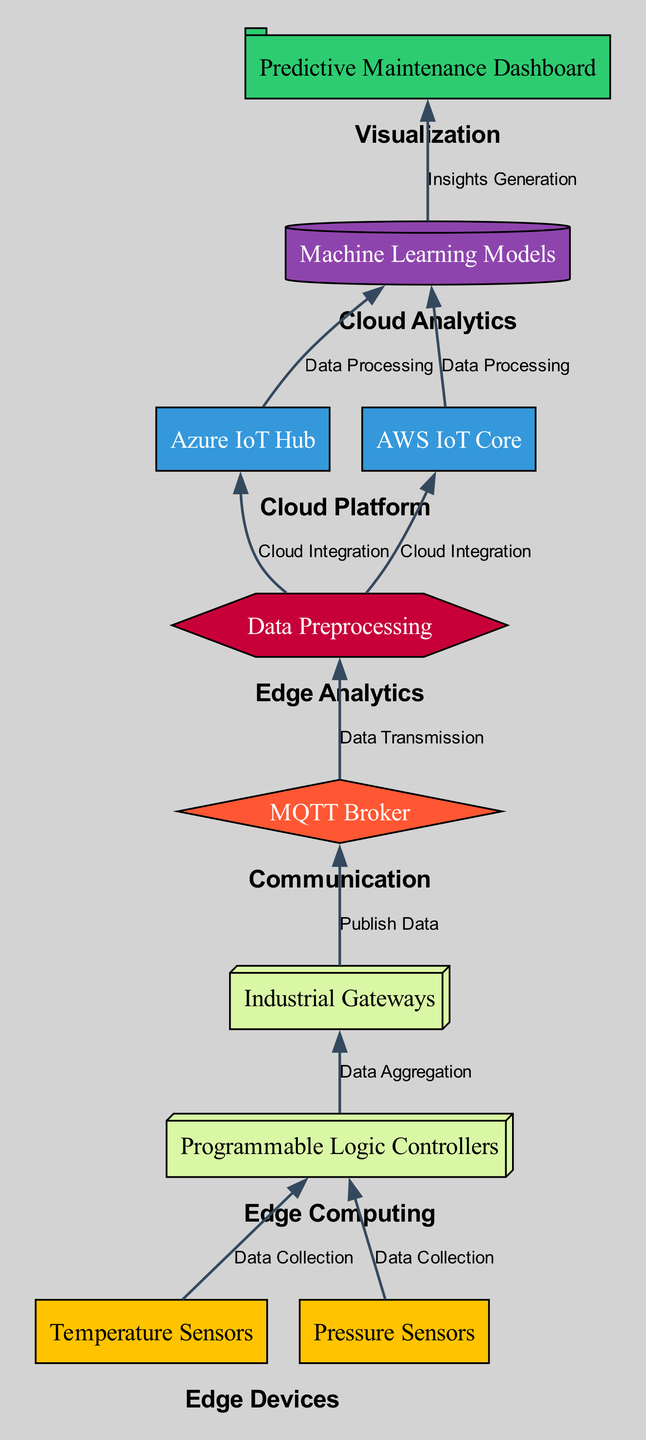What are the edge devices in the diagram? The edge devices listed in the diagram are Temperature Sensors and Pressure Sensors. They are represented as nodes with the category "Edge Devices."
Answer: Temperature Sensors, Pressure Sensors How many cloud platforms are shown? The diagram includes two cloud platforms: Azure IoT Hub and AWS IoT Core. Counting these gives a total of two cloud platforms.
Answer: 2 Which node generates insights? The node that generates insights is the Predictive Maintenance Dashboard, which is linked to Machine Learning Models as part of the insights generation process.
Answer: Predictive Maintenance Dashboard What is the relationship between Industrial Gateways and MQTT Broker? Industrial Gateways publish data to the MQTT Broker. The edge in the diagram indicates that Industrial Gateways send data toward the MQTT Broker using the label "Publish Data."
Answer: Publish Data Which category does Data Preprocessing belong to? Data Preprocessing is categorized as Edge Analytics in the diagram. It is positioned within the set of nodes associated with edge analytics functions.
Answer: Edge Analytics How many edges are there originating from Edge Computing nodes? The nodes in Edge Computing are Programmable Logic Controllers and Industrial Gateways. Programmable Logic Controllers connect to Industrial Gateways (1 edge) and Industrial Gateways connect to the MQTT Broker (1 edge). This results in a total of two edges originating from Edge Computing nodes.
Answer: 2 What is the first component in the data flow? The first component in the data flow is the Temperature Sensors, as it represents the starting point for data collection before moving through the other nodes.
Answer: Temperature Sensors What is the data aggregation step represented by? The data aggregation step is represented by the edge connecting Programmable Logic Controllers to Industrial Gateways, labeled "Data Aggregation." This indicates the process where data from the edge devices is aggregated before transmission.
Answer: Data Aggregation 